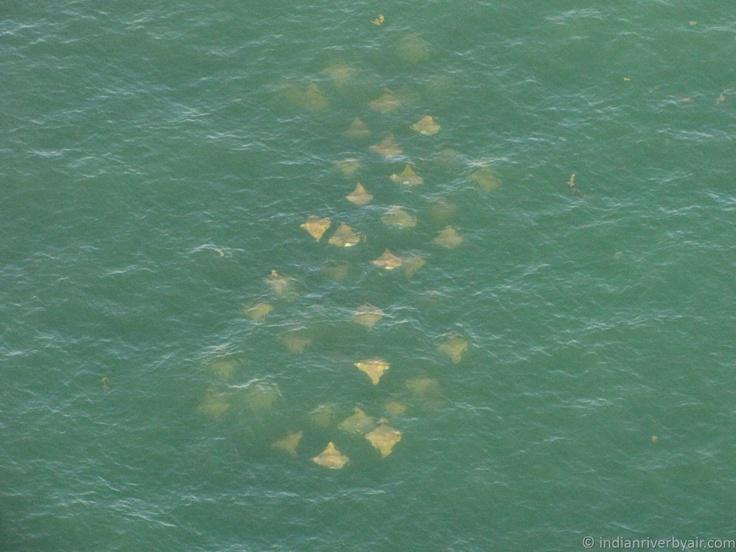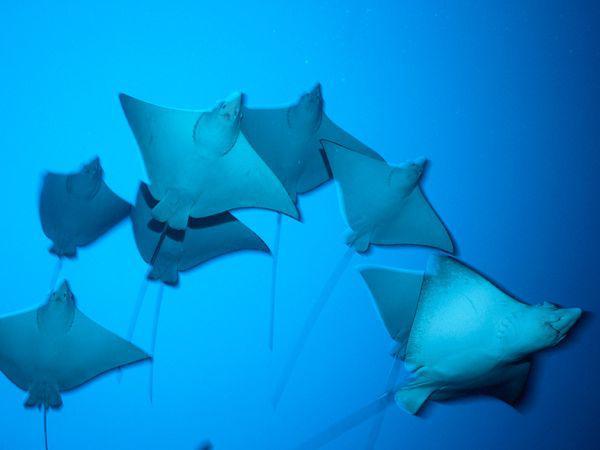The first image is the image on the left, the second image is the image on the right. For the images displayed, is the sentence "No image contains more than three stingray in the foreground, and no image contains other types of fish." factually correct? Answer yes or no. No. The first image is the image on the left, the second image is the image on the right. Considering the images on both sides, is "At least one of the images displays more than one of the manta rays, who seem to swim in larger groups regularly." valid? Answer yes or no. Yes. 